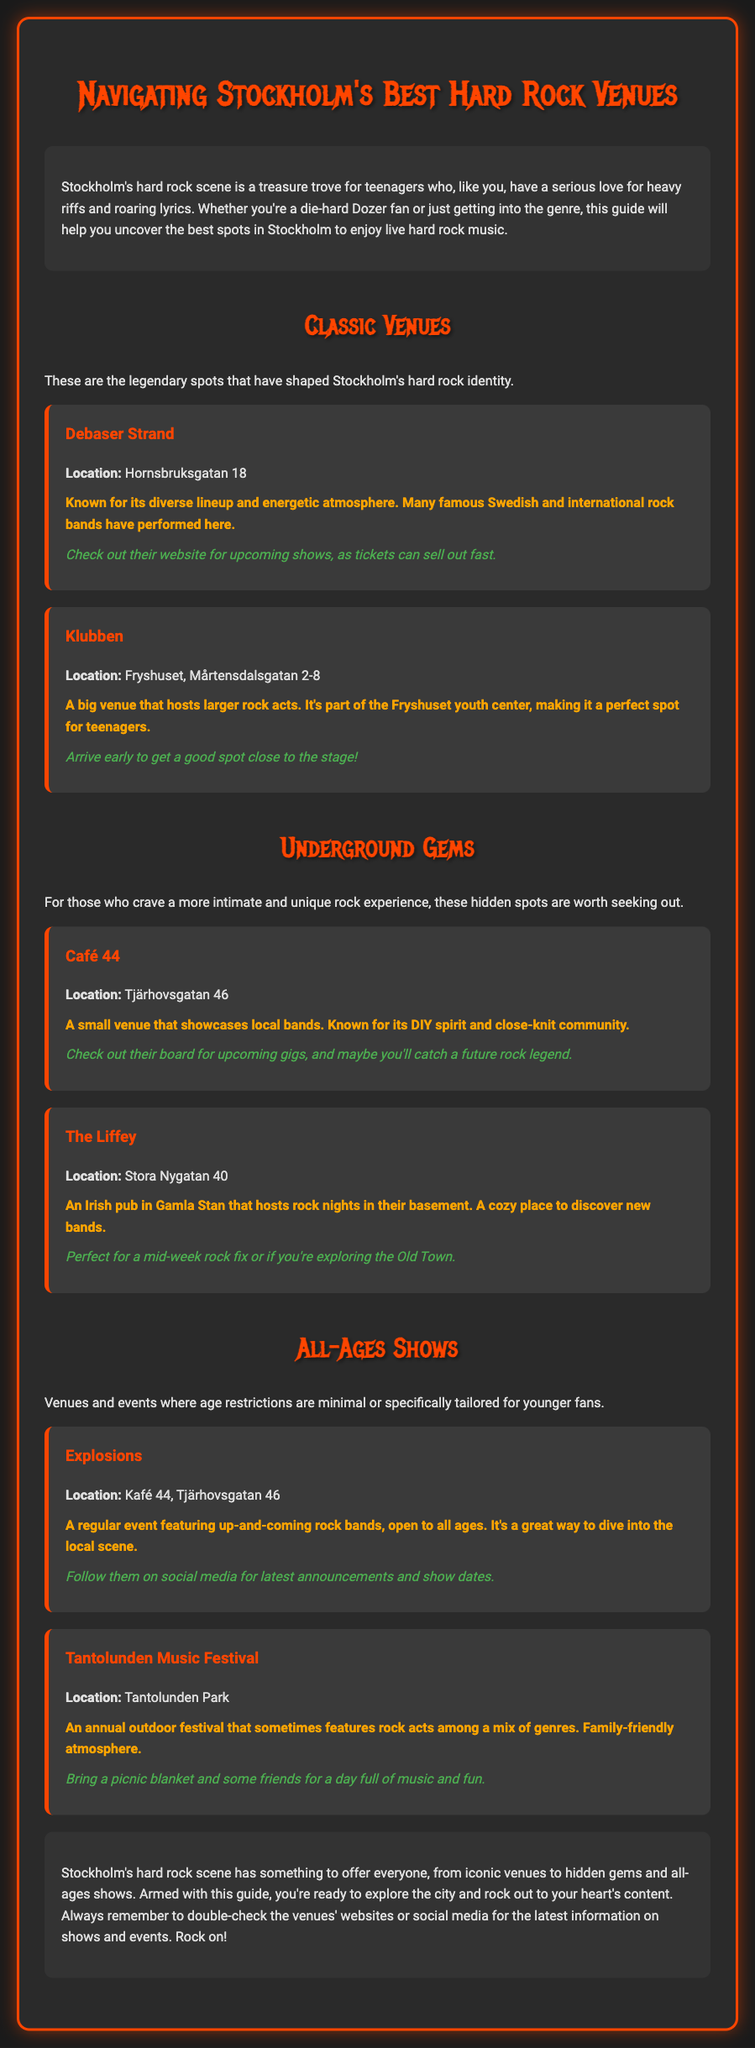What is the location of Debaser Strand? Debaser Strand is located at Hornsbruksgatan 18, as stated in the document.
Answer: Hornsbruksgatan 18 What type of events does Explosions feature? Explosions features up-and-coming rock bands, specifically highlighted in the all-ages shows section.
Answer: All ages rock bands What is the tip for visiting Klubben? The tip for visiting Klubben is to "Arrive early to get a good spot close to the stage!" which provides useful advice for concertgoers.
Answer: Arrive early Which venue is located at Tjärhovsgatan 46? Café 44 is located at Tjärhovsgatan 46, mentioned in the venue description.
Answer: Café 44 What is the atmosphere of the Tantolunden Music Festival? The atmosphere of the Tantolunden Music Festival is described as family-friendly, which indicates its suitability for all ages.
Answer: Family-friendly Which section discusses legendary spots? The section titled "Classic Venues" discusses legendary spots in Stockholm's hard rock scene.
Answer: Classic Venues How many classic venues are listed in the document? The document lists two classic venues: Debaser Strand and Klubben.
Answer: Two What does the conclusion encourage readers to do? The conclusion encourages readers to double-check the venues' websites or social media for the latest information on shows and events.
Answer: Double-check venues' websites What is a highlight of The Liffey? A highlight of The Liffey is that it hosts rock nights in their basement, which is specified in the venue description.
Answer: Hosts rock nights 